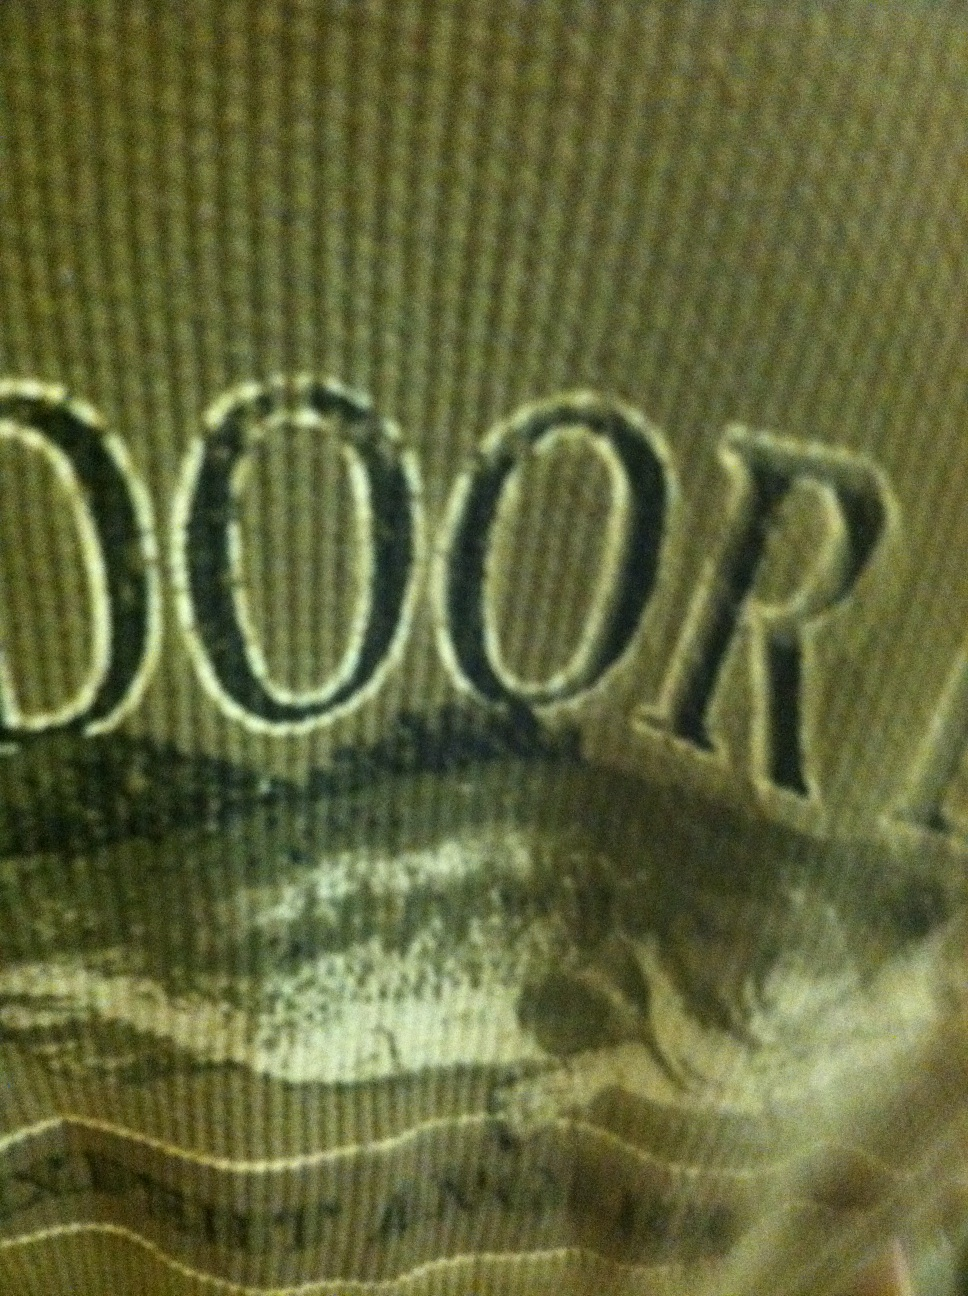What color is this shirt? The shirt is green. It's a subtle, earthy green color that complements the detailed design elements featured on it. 